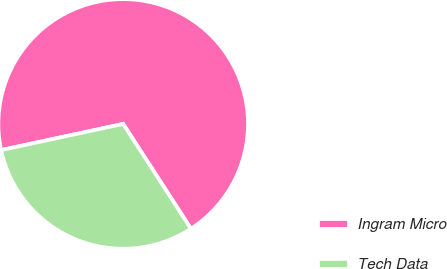Convert chart to OTSL. <chart><loc_0><loc_0><loc_500><loc_500><pie_chart><fcel>Ingram Micro<fcel>Tech Data<nl><fcel>69.23%<fcel>30.77%<nl></chart> 